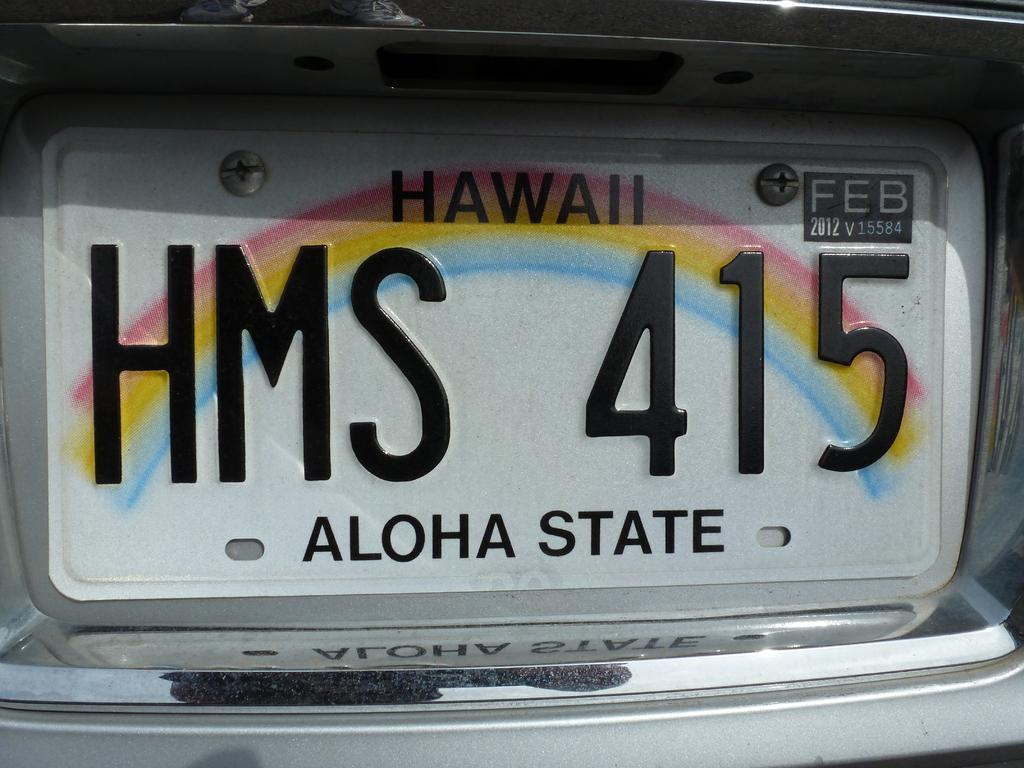What can be seen on the vehicle number plate in the image? The number plate has the text "HAWAII HMS 415" on it. What state is the number plate associated with? The number plate is associated with the "Aloha state," which is Hawaii. Is there a receipt for a soda purchase visible in the image? No, there is no receipt or soda purchase visible in the image; it only features a vehicle number plate. 